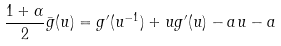Convert formula to latex. <formula><loc_0><loc_0><loc_500><loc_500>\frac { 1 + \alpha } 2 \bar { g } ( u ) = g ^ { \prime } ( u ^ { - 1 } ) + u g ^ { \prime } ( u ) - a u - a</formula> 